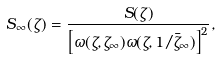Convert formula to latex. <formula><loc_0><loc_0><loc_500><loc_500>S _ { \infty } ( \zeta ) = \frac { S ( \zeta ) } { \left [ \omega ( \zeta , \zeta _ { \infty } ) \omega ( \zeta , 1 / \bar { \zeta } _ { \infty } ) \right ] ^ { 2 } } ,</formula> 